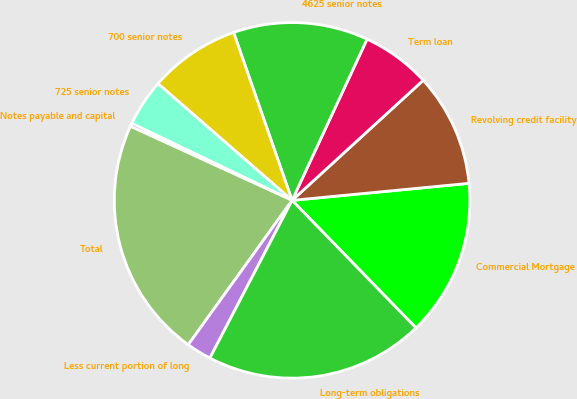Convert chart to OTSL. <chart><loc_0><loc_0><loc_500><loc_500><pie_chart><fcel>Commercial Mortgage<fcel>Revolving credit facility<fcel>Term loan<fcel>4625 senior notes<fcel>700 senior notes<fcel>725 senior notes<fcel>Notes payable and capital<fcel>Total<fcel>Less current portion of long<fcel>Long-term obligations<nl><fcel>14.26%<fcel>10.27%<fcel>6.27%<fcel>12.26%<fcel>8.27%<fcel>4.28%<fcel>0.28%<fcel>21.91%<fcel>2.28%<fcel>19.91%<nl></chart> 